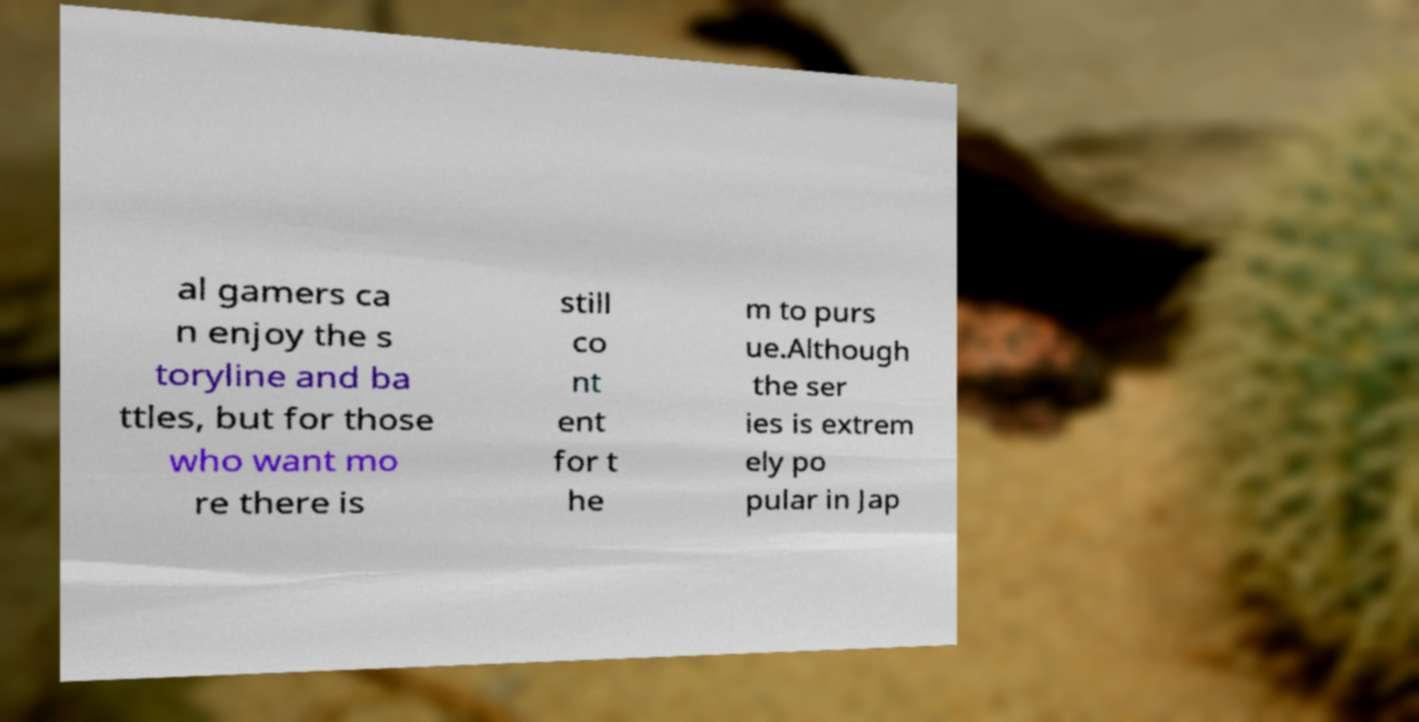Please read and relay the text visible in this image. What does it say? al gamers ca n enjoy the s toryline and ba ttles, but for those who want mo re there is still co nt ent for t he m to purs ue.Although the ser ies is extrem ely po pular in Jap 